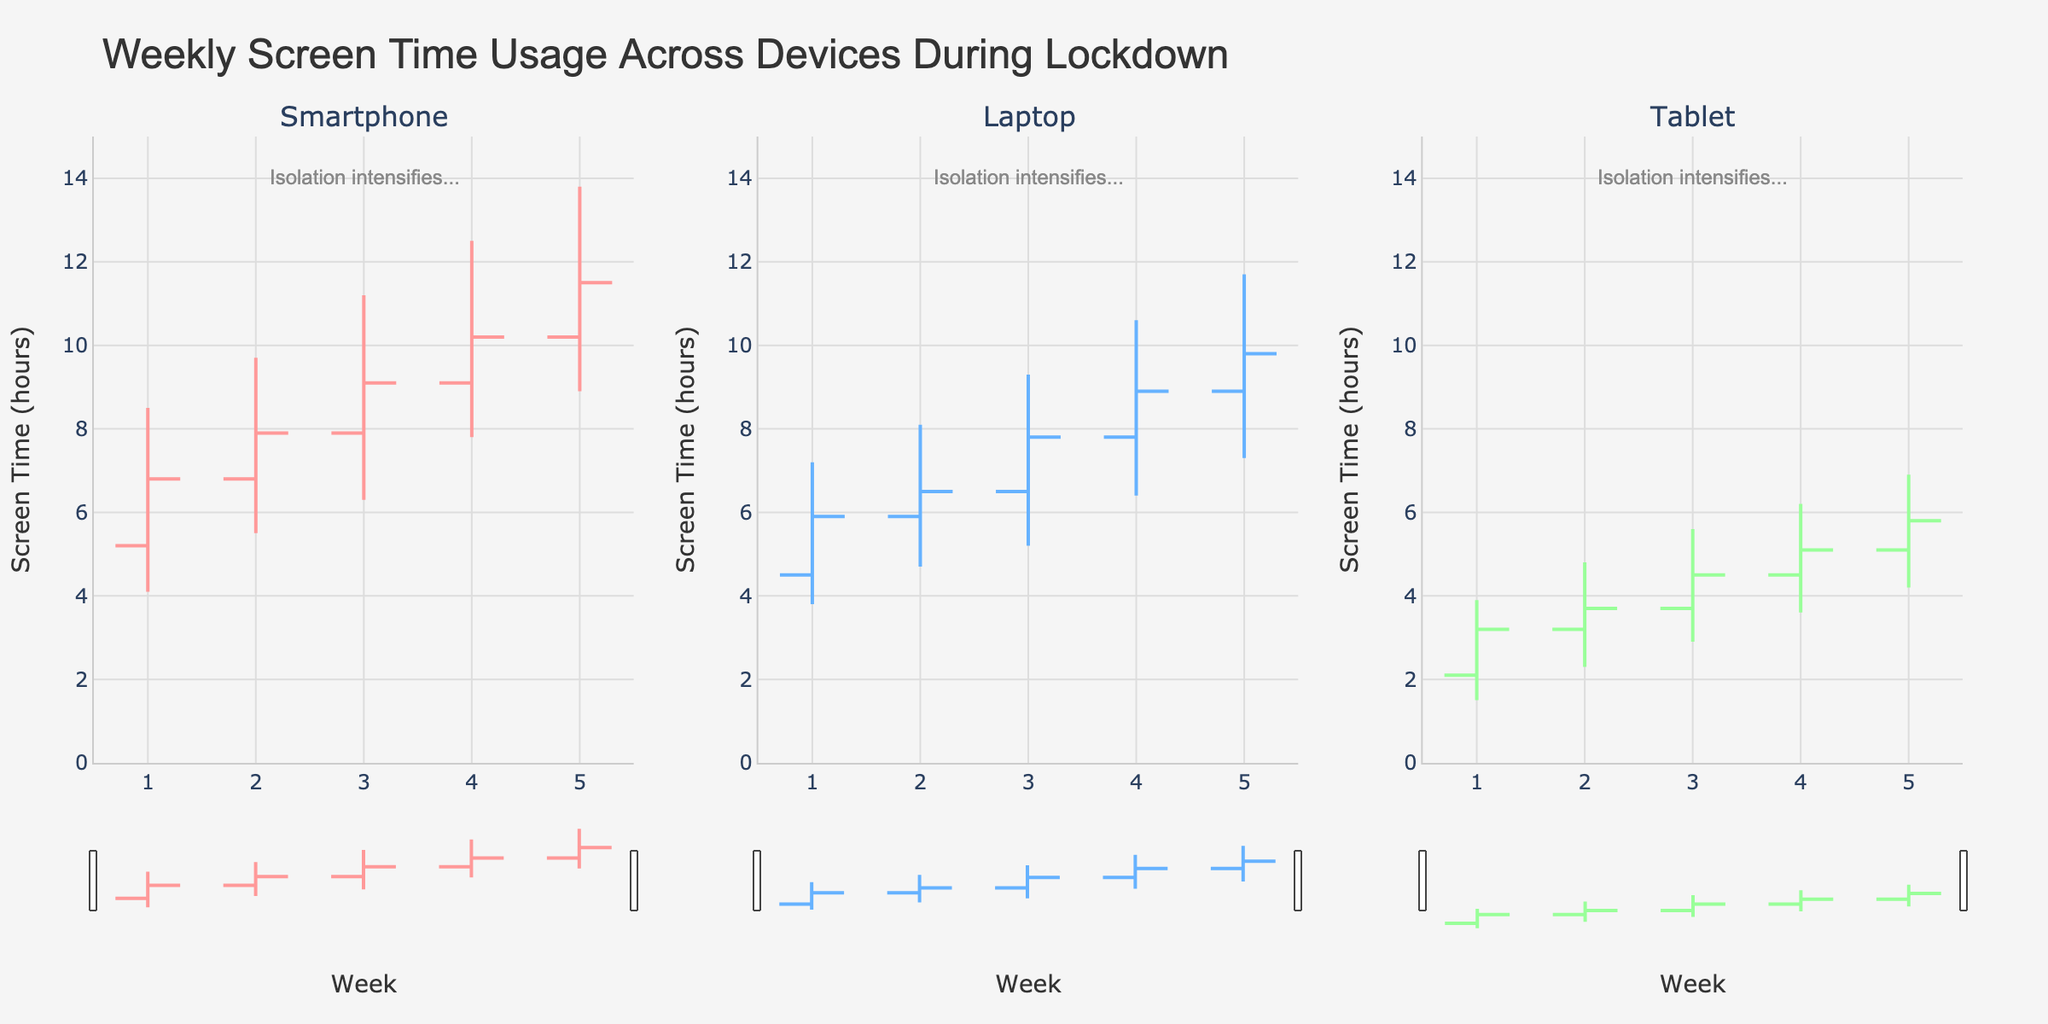Which device had the highest peak screen time in Week 3? The OHLC chart shows the high values for each week and device. For Week 3, the highest peak values are:
  - Smartphone: 11.2 hours
  - Laptop: 9.3 hours
  - Tablet: 5.6 hours
  The Smartphone had the highest peak screen time in Week 3.
Answer: Smartphone What was the closing screen time for Tablets in Week 5? The OHLC chart provides the closing values for data points. For Week 5, the closing value for Tablets is 5.8 hours.
Answer: 5.8 hours During which week did Laptops have the lowest peak screen time? The OHLC chart shows the high values for the weekly data points. The lowest high value for Laptops is observed in Week 1 with 7.2 hours.
Answer: Week 1 How did the screen time for Smartphones change from Week 2 to Week 3? To determine the change, compare the closing values for Smartphones in Week 2 and Week 3:
  - Week 2 close: 7.9 hours
  - Week 3 close: 9.1 hours
  The change is 9.1 - 7.9 = 1.2 hours increase.
Answer: +1.2 hours What was the range of screen time for Tablets in Week 4? The range of screen time is the difference between the high and low values. For Week 4:
  - High: 6.2 hours
  - Low: 3.6 hours
  The range is 6.2 - 3.6 = 2.6 hours.
Answer: 2.6 hours Which device had the highest increase in screen time from Week 1 to Week 5? To determine the highest increase, calculate the difference between the closing values in Week 1 and Week 5 for each device:
  - Smartphone: 11.5 - 6.8 = 4.7 hours
  - Laptop: 9.8 - 5.9 = 3.9 hours
  - Tablet: 5.8 - 3.2 = 2.6 hours
  The Smartphone had the highest increase in screen time.
Answer: Smartphone What was the average weekly closing screen time for Laptops over the 5 weeks? The average weekly closing screen time for Laptops can be found by calculating the mean of the closing values:
  - Week 1: 5.9 hours
  - Week 2: 6.5 hours
  - Week 3: 7.8 hours
  - Week 4: 8.9 hours
  - Week 5: 9.8 hours
  (5.9 + 6.5 + 7.8 + 8.9 + 9.8) / 5 = 7.78 hours.
Answer: 7.78 hours How does the range of screen time vary across devices in Week 1? The range is calculated as the difference between high and low values. For Week 1:
  - Smartphone: 8.5 - 4.1 = 4.4 hours
  - Laptop: 7.2 - 3.8 = 3.4 hours
  - Tablet: 3.9 - 1.5 = 2.4 hours
  The ranges are 4.4 hours (Smartphone), 3.4 hours (Laptop), and 2.4 hours (Tablet).
Answer: 4.4 (Smartphone), 3.4 (Laptop), 2.4 (Tablet) 